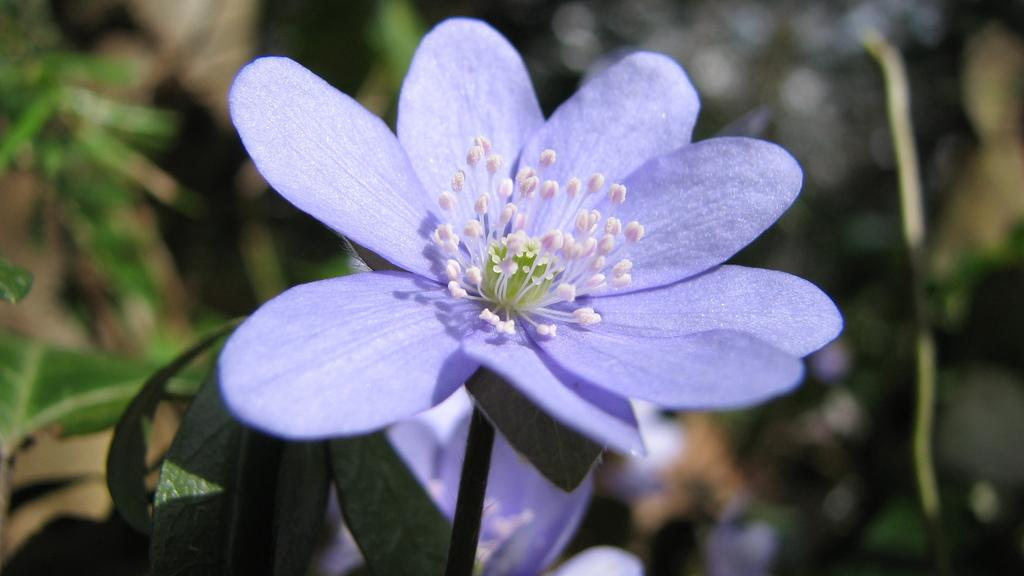What is the main subject of the picture? The main subject of the picture is a flower. Can you describe the color of the flower? The flower is purple. What other parts of the flower can be seen in the image? The flower has a stem and leaves. How is the background of the image depicted? The backdrop of the image is blurred. What type of beef is being served in the image? There is no beef present in the image; it features a purple flower with a stem and leaves. What does the worm believe about the flower in the image? There are no worms present in the image, and therefore no beliefs about the flower can be attributed to them. 